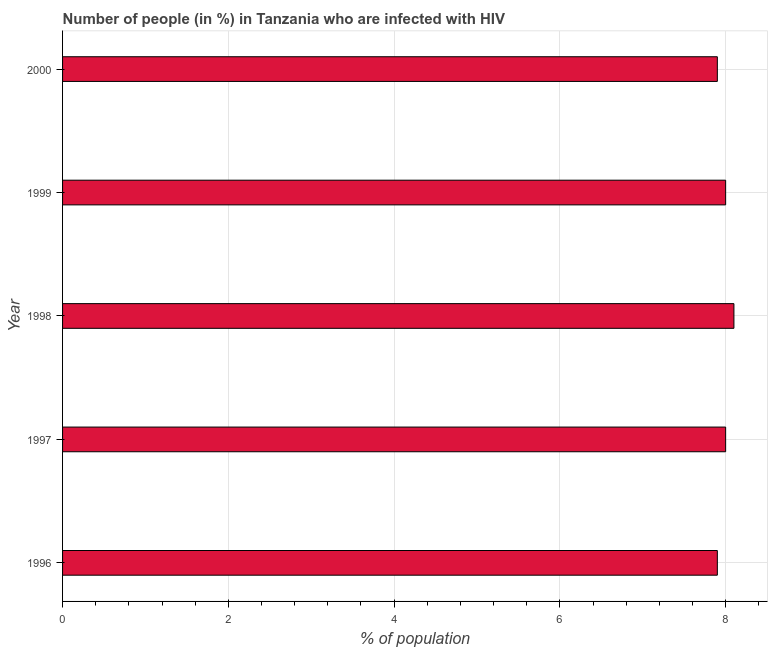What is the title of the graph?
Ensure brevity in your answer.  Number of people (in %) in Tanzania who are infected with HIV. What is the label or title of the X-axis?
Keep it short and to the point. % of population. What is the label or title of the Y-axis?
Offer a very short reply. Year. What is the number of people infected with hiv in 1999?
Your answer should be very brief. 8. Across all years, what is the maximum number of people infected with hiv?
Provide a short and direct response. 8.1. Across all years, what is the minimum number of people infected with hiv?
Make the answer very short. 7.9. In which year was the number of people infected with hiv minimum?
Offer a very short reply. 1996. What is the sum of the number of people infected with hiv?
Your answer should be compact. 39.9. What is the average number of people infected with hiv per year?
Make the answer very short. 7.98. In how many years, is the number of people infected with hiv greater than 4.8 %?
Ensure brevity in your answer.  5. Do a majority of the years between 2000 and 1997 (inclusive) have number of people infected with hiv greater than 3.6 %?
Your response must be concise. Yes. What is the ratio of the number of people infected with hiv in 1996 to that in 1997?
Provide a succinct answer. 0.99. Is the number of people infected with hiv in 1996 less than that in 1997?
Your answer should be very brief. Yes. Is the difference between the number of people infected with hiv in 1997 and 1998 greater than the difference between any two years?
Offer a terse response. No. What is the difference between the highest and the second highest number of people infected with hiv?
Provide a succinct answer. 0.1. How many bars are there?
Make the answer very short. 5. What is the difference between two consecutive major ticks on the X-axis?
Offer a very short reply. 2. What is the % of population in 1996?
Keep it short and to the point. 7.9. What is the % of population of 1999?
Provide a succinct answer. 8. What is the difference between the % of population in 1996 and 1998?
Your answer should be compact. -0.2. What is the difference between the % of population in 1996 and 1999?
Offer a terse response. -0.1. What is the difference between the % of population in 1997 and 1998?
Provide a succinct answer. -0.1. What is the difference between the % of population in 1997 and 1999?
Ensure brevity in your answer.  0. What is the difference between the % of population in 1997 and 2000?
Your response must be concise. 0.1. What is the difference between the % of population in 1998 and 1999?
Provide a succinct answer. 0.1. What is the ratio of the % of population in 1996 to that in 1998?
Provide a short and direct response. 0.97. What is the ratio of the % of population in 1996 to that in 2000?
Give a very brief answer. 1. What is the ratio of the % of population in 1997 to that in 2000?
Give a very brief answer. 1.01. What is the ratio of the % of population in 1999 to that in 2000?
Offer a very short reply. 1.01. 